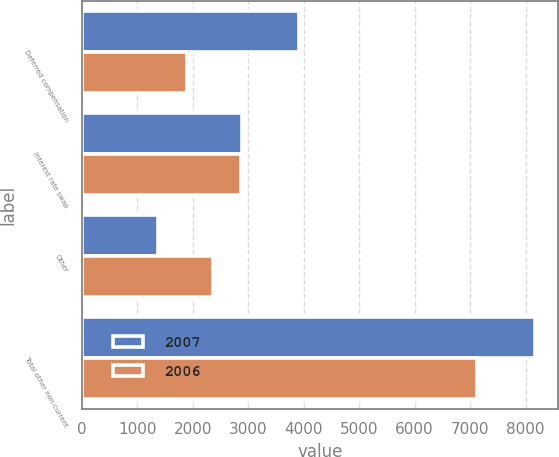<chart> <loc_0><loc_0><loc_500><loc_500><stacked_bar_chart><ecel><fcel>Deferred compensation<fcel>Interest rate swap<fcel>Other<fcel>Total other non-current<nl><fcel>2007<fcel>3915<fcel>2886<fcel>1377<fcel>8178<nl><fcel>2006<fcel>1888<fcel>2872<fcel>2363<fcel>7123<nl></chart> 